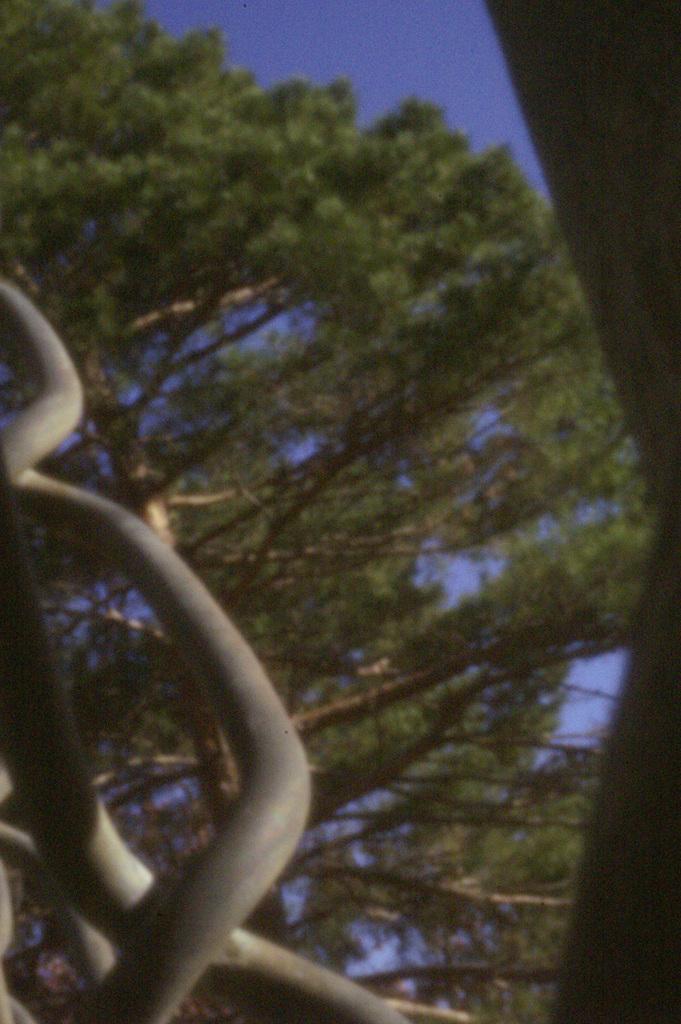Please provide a concise description of this image. In this image there are trees, objects and blue sky. 